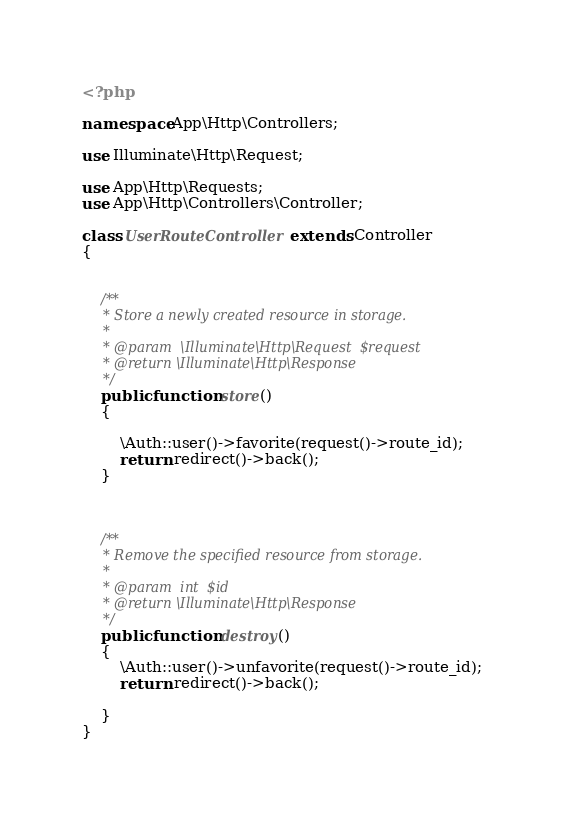<code> <loc_0><loc_0><loc_500><loc_500><_PHP_><?php

namespace App\Http\Controllers;

use Illuminate\Http\Request;

use App\Http\Requests;
use App\Http\Controllers\Controller;

class UserRouteController extends Controller
{


    /**
     * Store a newly created resource in storage.
     *
     * @param  \Illuminate\Http\Request  $request
     * @return \Illuminate\Http\Response
     */
    public function store()
    {
        
        \Auth::user()->favorite(request()->route_id);
        return redirect()->back();
    }

  

    /**
     * Remove the specified resource from storage.
     *
     * @param  int  $id
     * @return \Illuminate\Http\Response
     */
    public function destroy()
    {
        \Auth::user()->unfavorite(request()->route_id);
        return redirect()->back();

    }
}
</code> 